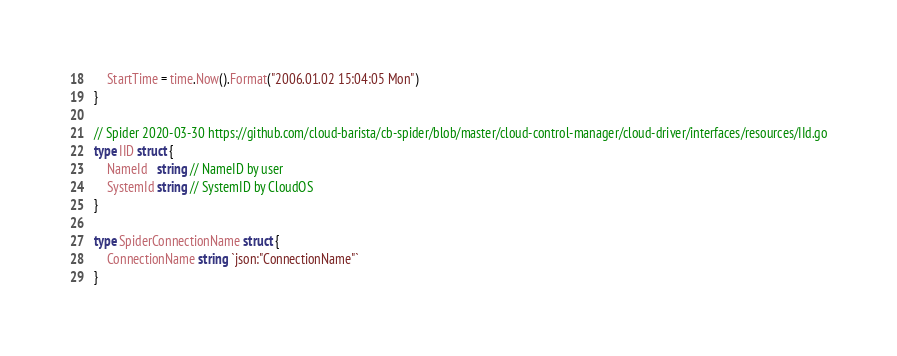Convert code to text. <code><loc_0><loc_0><loc_500><loc_500><_Go_>	StartTime = time.Now().Format("2006.01.02 15:04:05 Mon")
}

// Spider 2020-03-30 https://github.com/cloud-barista/cb-spider/blob/master/cloud-control-manager/cloud-driver/interfaces/resources/IId.go
type IID struct {
	NameId   string // NameID by user
	SystemId string // SystemID by CloudOS
}

type SpiderConnectionName struct {
	ConnectionName string `json:"ConnectionName"`
}
</code> 